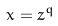<formula> <loc_0><loc_0><loc_500><loc_500>x = z ^ { q }</formula> 